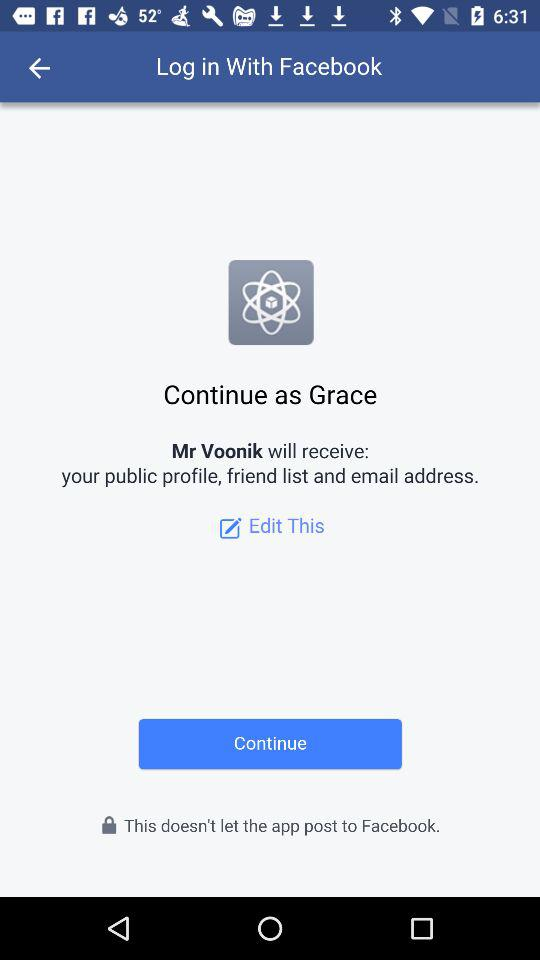What is the application name? The application names are "Facebook" and "Mr Voonik". 